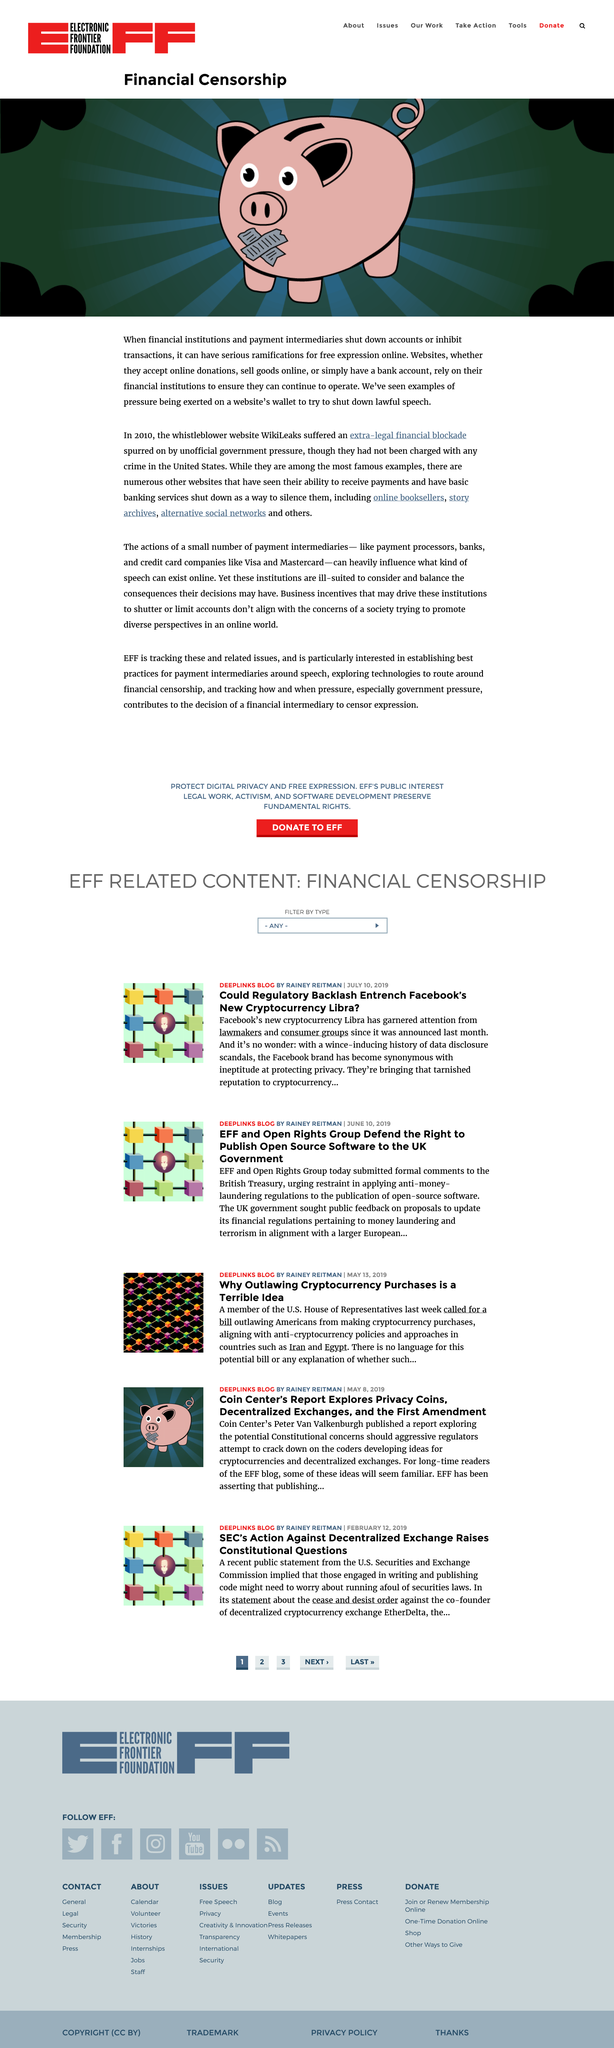Outline some significant characteristics in this image. Yes, the extra-legal financial blockade suffered by WikiLeaks is an example of financial censorship. Websites rely on their financial institutions to ensure their continued operation. Yes, pressure is sometimes exerted on a website's wallet in an attempt to silence lawful speech. 